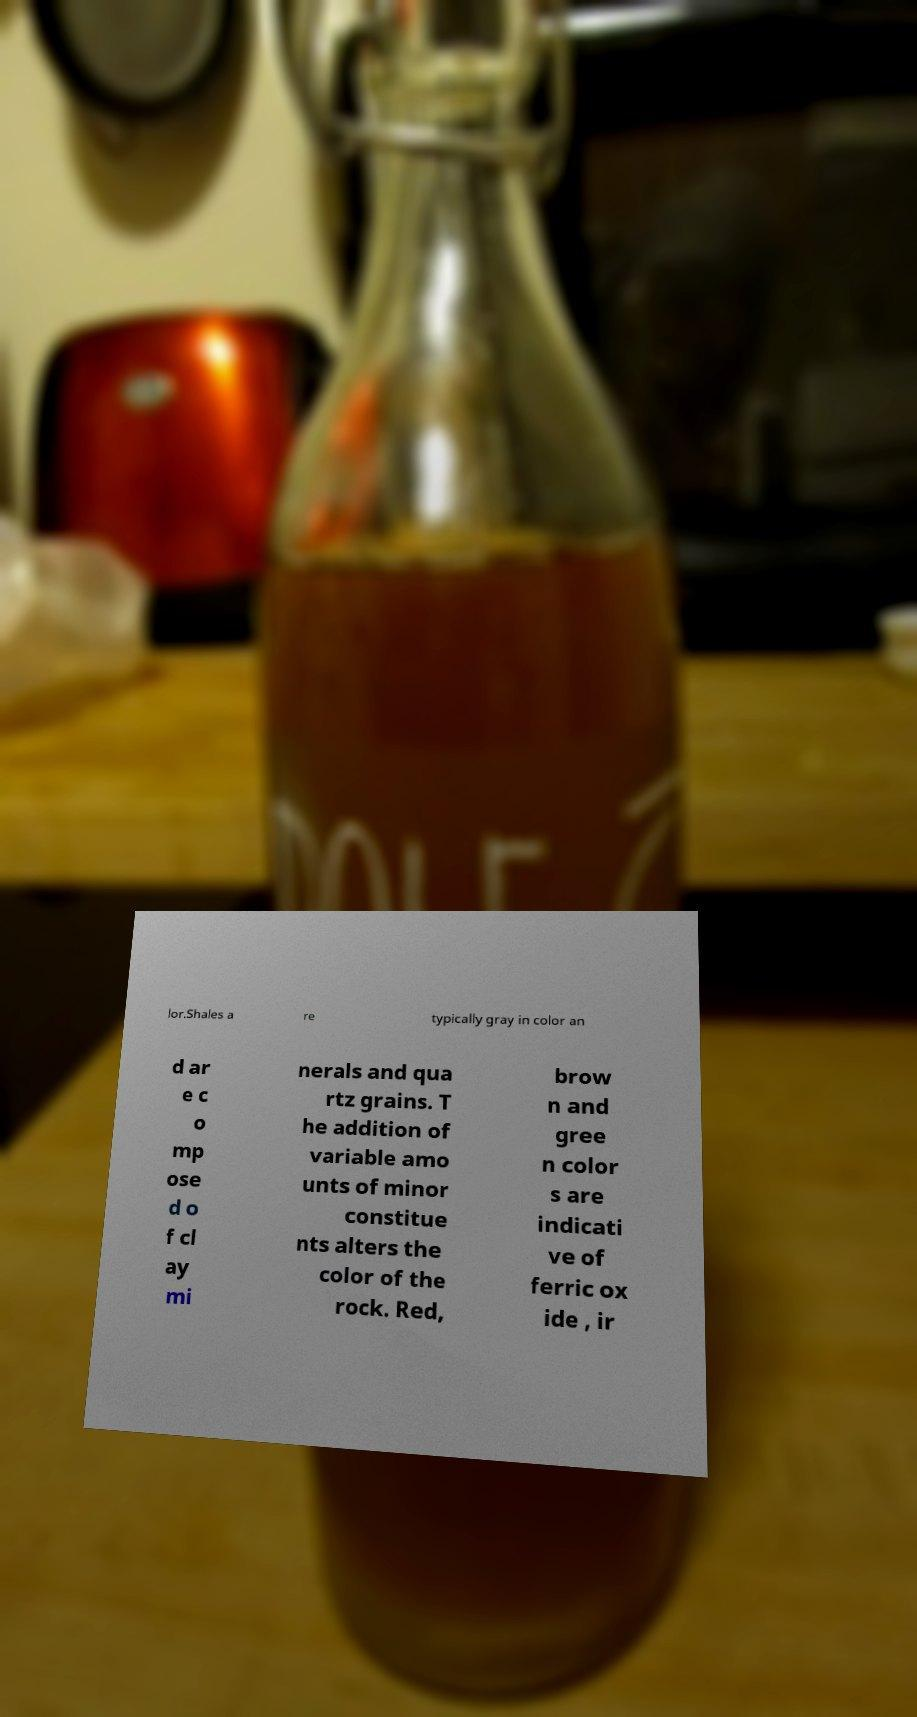Please identify and transcribe the text found in this image. lor.Shales a re typically gray in color an d ar e c o mp ose d o f cl ay mi nerals and qua rtz grains. T he addition of variable amo unts of minor constitue nts alters the color of the rock. Red, brow n and gree n color s are indicati ve of ferric ox ide , ir 